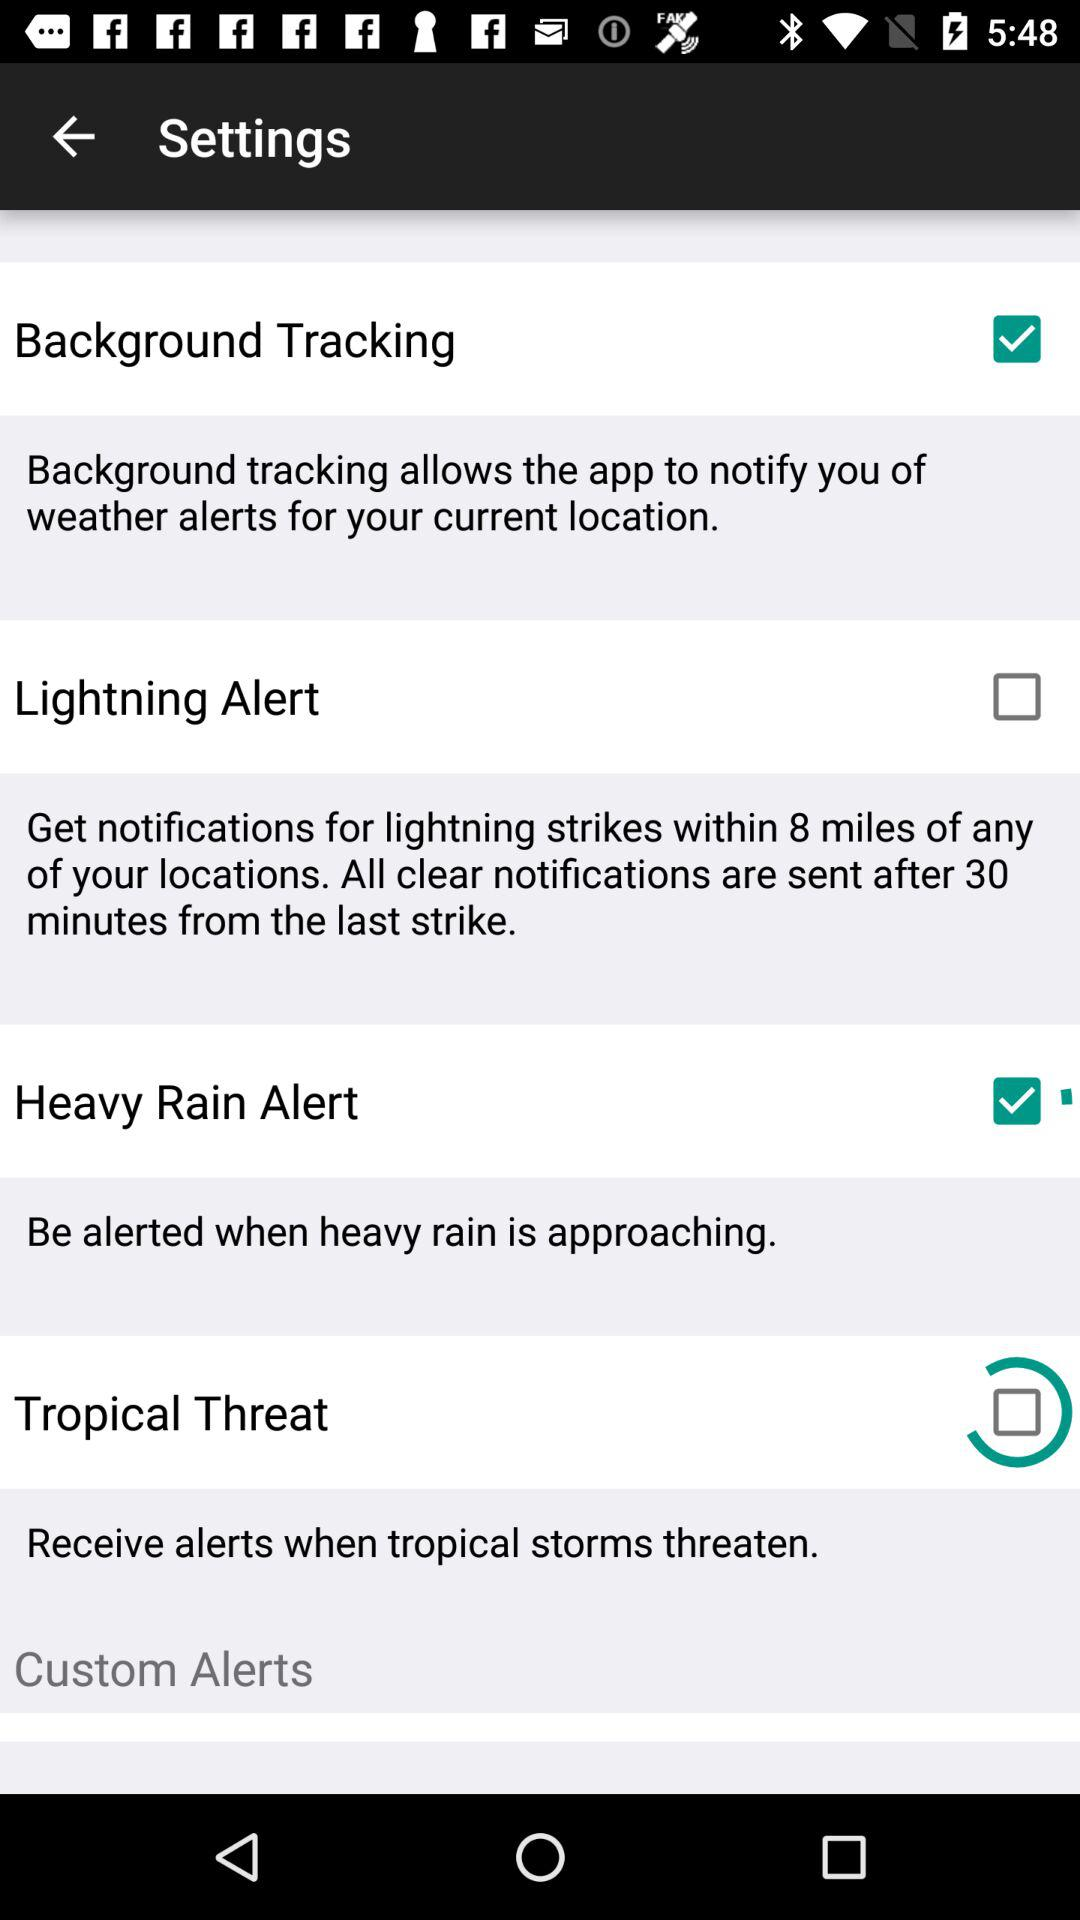When do the alerts receive? The alerts are received when tropical storms threaten. 